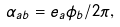<formula> <loc_0><loc_0><loc_500><loc_500>\alpha _ { a b } = e _ { a } \phi _ { b } / 2 \pi ,</formula> 